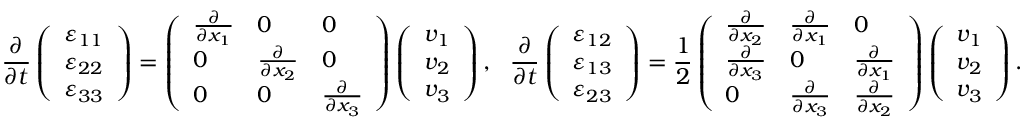Convert formula to latex. <formula><loc_0><loc_0><loc_500><loc_500>\frac { \partial } { \partial t } \left ( \begin{array} { l } { \varepsilon _ { 1 1 } } \\ { \varepsilon _ { 2 2 } } \\ { \varepsilon _ { 3 3 } } \end{array} \right ) = \left ( \begin{array} { l l l } { \frac { \partial } { \partial x _ { 1 } } } & { 0 } & { 0 } \\ { 0 } & { \frac { \partial } { \partial x _ { 2 } } } & { 0 } \\ { 0 } & { 0 } & { \frac { \partial } { \partial x _ { 3 } } } \end{array} \right ) \left ( \begin{array} { l } { v _ { 1 } } \\ { v _ { 2 } } \\ { v _ { 3 } } \end{array} \right ) , \frac { \partial } { \partial t } \left ( \begin{array} { l } { \varepsilon _ { 1 2 } } \\ { \varepsilon _ { 1 3 } } \\ { \varepsilon _ { 2 3 } } \end{array} \right ) = \frac { 1 } { 2 } \left ( \begin{array} { l l l } { \frac { \partial } { \partial x _ { 2 } } } & { \frac { \partial } { \partial x _ { 1 } } } & { 0 } \\ { \frac { \partial } { \partial x _ { 3 } } } & { 0 } & { \frac { \partial } { \partial x _ { 1 } } } \\ { 0 } & { \frac { \partial } { \partial x _ { 3 } } } & { \frac { \partial } { \partial x _ { 2 } } } \end{array} \right ) \left ( \begin{array} { l } { v _ { 1 } } \\ { v _ { 2 } } \\ { v _ { 3 } } \end{array} \right ) .</formula> 